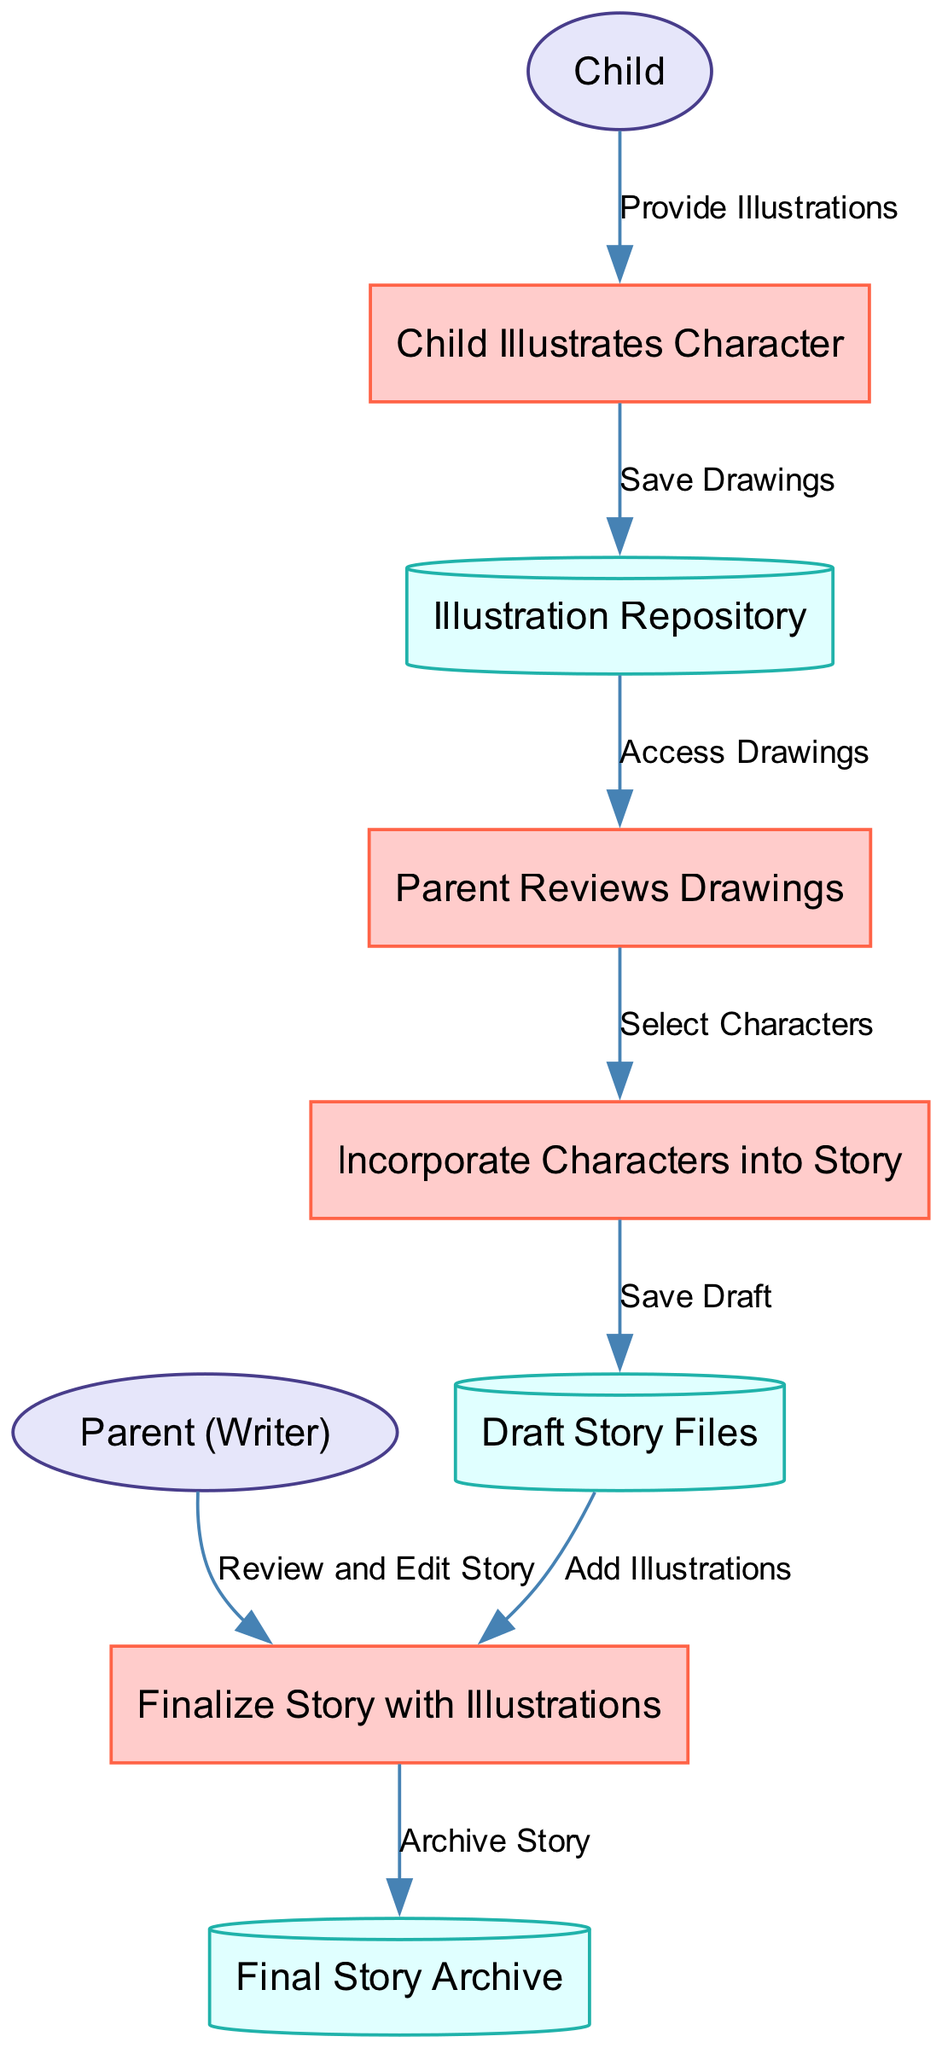What is the first process in the diagram? The first process listed in the diagram is "Child Illustrates Character," which is identified as process ID 1.
Answer: Child Illustrates Character How many external entities are present in the diagram? There are two external entities in the diagram: "Child" and "Parent (Writer)" identified by IDs 5 and 6.
Answer: 2 Which process directly follows "Parent Reviews Drawings"? The process that directly follows "Parent Reviews Drawings" is "Incorporate Characters into Story," as indicated by the data flow linking these two processes.
Answer: Incorporate Characters into Story Which data store is linked to the final process? The final process "Finalize Story with Illustrations" is linked to the data store "Final Story Archive," shown by the data flow connecting the two.
Answer: Final Story Archive What type of data flow occurs from "Child Illustrates Character" to "Illustration Repository"? The data flow from "Child Illustrates Character" to "Illustration Repository" is labeled "Save Drawings," which indicates the action taken with the data.
Answer: Save Drawings Which external entity contributes illustrations into the process? The external entity contributing illustrations into the process is "Child," as shown by the flow leading from the Child to the process "Child Illustrates Character."
Answer: Child Identify the data store where draft stories are saved. The data store where draft stories are saved is "Draft Story Files," which is specifically labeled for that purpose in the diagram.
Answer: Draft Story Files What is the last action that occurs before archiving the story? The last action before archiving the story is labeled "Add Illustrations," which is the final step taken towards finalizing the story with its illustrations.
Answer: Add Illustrations 